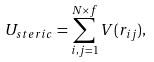Convert formula to latex. <formula><loc_0><loc_0><loc_500><loc_500>U _ { s t e r i c } = \sum _ { i , j = 1 } ^ { N \times f } V ( r _ { i j } ) ,</formula> 